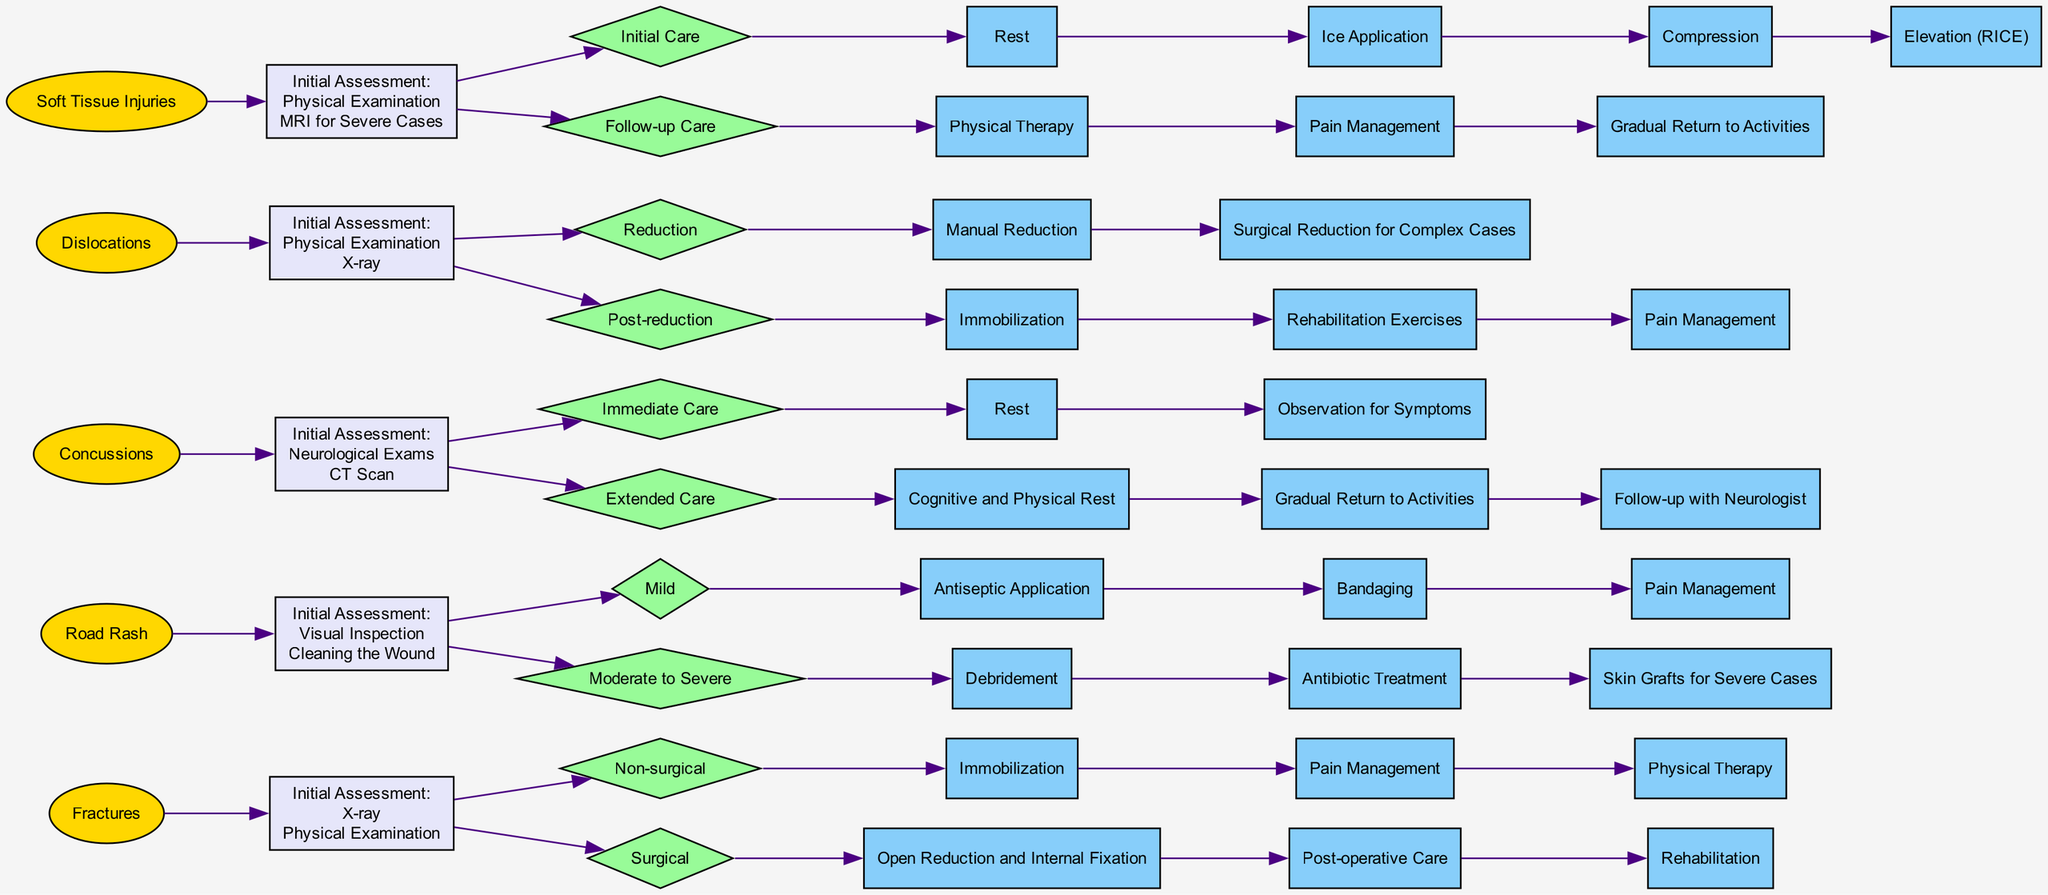What are the common locations for fractures? The diagram lists the common locations associated with fractures. By looking at the "Fractures" section in the diagram, we can identify and list the locations mentioned: Clavicle, Wrist, and Ribs.
Answer: Clavicle, Wrist, Ribs How many treatment pathways are there for concussions? The diagram is analyzed for the concussions section, which outlines the treatment pathways. It starts with two main categories: Immediate Care and Extended Care. Each category contains separate steps, but as categories, there are only two pathways.
Answer: 2 What initial assessments are used for road rash? To answer this question, the diagram is reviewed under the "Road Rash" category, which specifies the initial assessments mentioned. The two initial assessments listed are Visual Inspection and Cleaning the Wound.
Answer: Visual Inspection, Cleaning the Wound What is the primary method of initial care for soft tissue injuries? The diagram requires looking at the "Soft Tissue Injuries" section, which provides an overview of the initial care steps. The main method listed is known as RICE, which stands for Rest, Ice Application, Compression, Elevation.
Answer: RICE What is the first step in the surgical treatment of fractures? We need to look at the "Fractures" section, focusing on the surgical treatment pathway. The first surgical step listed is Open Reduction and Internal Fixation, which is specified as the initial action in surgical management for fractures.
Answer: Open Reduction and Internal Fixation What are the symptoms of concussions? To address this, the diagram is examined for the "Concussions" section. The symptoms listed include Headache, Confusion, and Dizziness. Therefore, we list these three symptoms as the answer.
Answer: Headache, Confusion, Dizziness What type of injuries fall under the category of soft tissue injuries? An analysis of the "Soft Tissue Injuries" section leads to identifying types mentioned: Bruises, Sprains, and Strains.
Answer: Bruises, Sprains, Strains How many steps are there in the moderate to severe treatment pathway for road rash? The diagram indicates that the treatment pathway for moderate to severe road rash consists of three main steps: Debridement, Antibiotic Treatment, and Skin Grafts for Severe Cases. Thus, we count these steps.
Answer: 3 